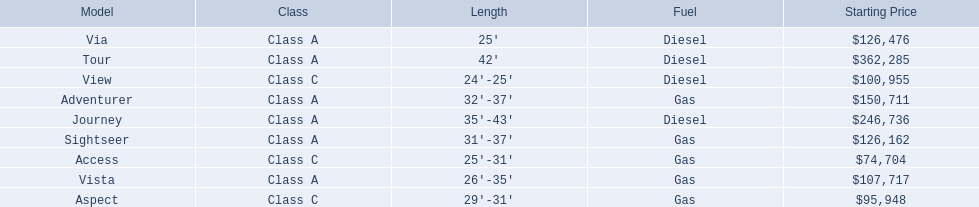What models are available from winnebago industries? Tour, Journey, Adventurer, Via, Sightseer, Vista, View, Aspect, Access. What are their starting prices? $362,285, $246,736, $150,711, $126,476, $126,162, $107,717, $100,955, $95,948, $74,704. Which model has the most costly starting price? Tour. 